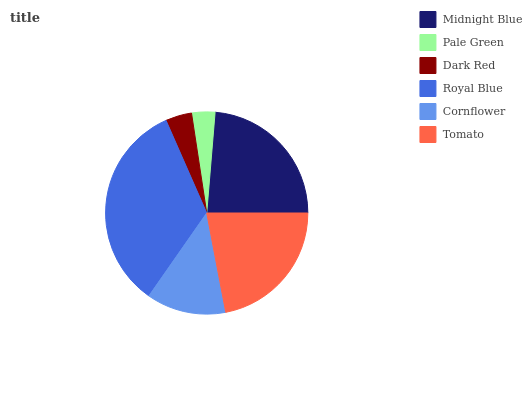Is Pale Green the minimum?
Answer yes or no. Yes. Is Royal Blue the maximum?
Answer yes or no. Yes. Is Dark Red the minimum?
Answer yes or no. No. Is Dark Red the maximum?
Answer yes or no. No. Is Dark Red greater than Pale Green?
Answer yes or no. Yes. Is Pale Green less than Dark Red?
Answer yes or no. Yes. Is Pale Green greater than Dark Red?
Answer yes or no. No. Is Dark Red less than Pale Green?
Answer yes or no. No. Is Tomato the high median?
Answer yes or no. Yes. Is Cornflower the low median?
Answer yes or no. Yes. Is Dark Red the high median?
Answer yes or no. No. Is Dark Red the low median?
Answer yes or no. No. 